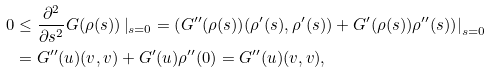<formula> <loc_0><loc_0><loc_500><loc_500>0 & \leq \frac { \partial ^ { 2 } } { \partial s ^ { 2 } } G ( \rho ( s ) ) \left | _ { s = 0 } = \left ( G ^ { \prime \prime } ( \rho ( s ) ) ( \rho ^ { \prime } ( s ) , \rho ^ { \prime } ( s ) ) + G ^ { \prime } ( \rho ( s ) ) \rho ^ { \prime \prime } ( s ) \right ) \right | _ { s = 0 } \\ & = G ^ { \prime \prime } ( u ) ( v , v ) + G ^ { \prime } ( u ) \rho ^ { \prime \prime } ( 0 ) = G ^ { \prime \prime } ( u ) ( v , v ) ,</formula> 